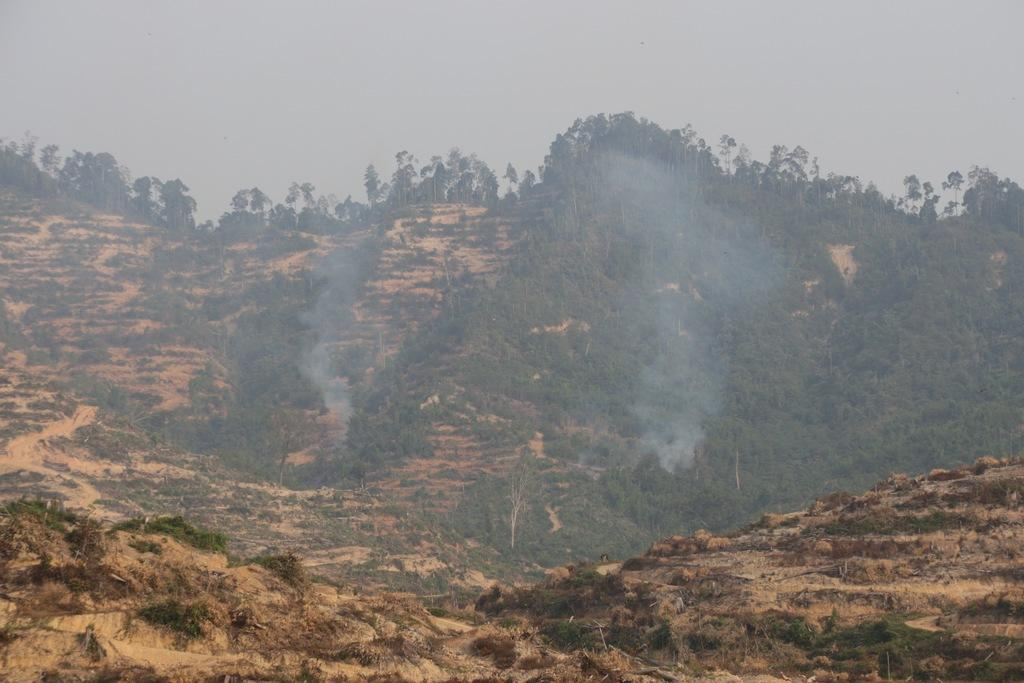What geographical feature is present in the image? There is a hill in the image. What can be found on the hill? The hill has trees. What else is visible in the image besides the hill and trees? There is smoke in the image. What can be seen in the background of the image? The sky is visible in the background of the image. What type of hall can be seen in the middle of the image? There is no hall present in the image; it features a hill with trees and smoke. Can you hear the sound of the hearing in the image? There is no hearing or sound present in the image, as it is a visual representation of a hill with trees and smoke. 